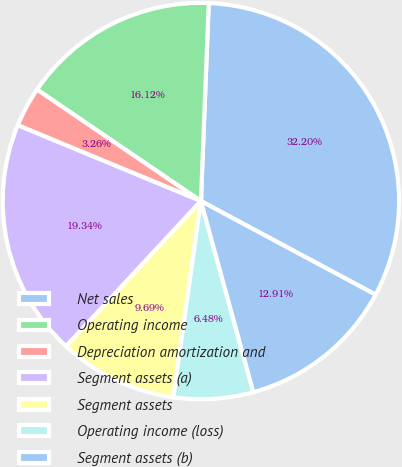Convert chart. <chart><loc_0><loc_0><loc_500><loc_500><pie_chart><fcel>Net sales<fcel>Operating income<fcel>Depreciation amortization and<fcel>Segment assets (a)<fcel>Segment assets<fcel>Operating income (loss)<fcel>Segment assets (b)<nl><fcel>32.2%<fcel>16.12%<fcel>3.26%<fcel>19.34%<fcel>9.69%<fcel>6.48%<fcel>12.91%<nl></chart> 